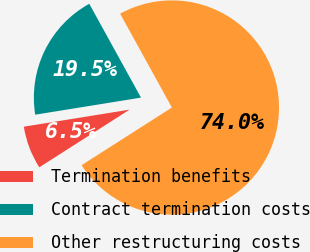<chart> <loc_0><loc_0><loc_500><loc_500><pie_chart><fcel>Termination benefits<fcel>Contract termination costs<fcel>Other restructuring costs<nl><fcel>6.5%<fcel>19.53%<fcel>73.98%<nl></chart> 